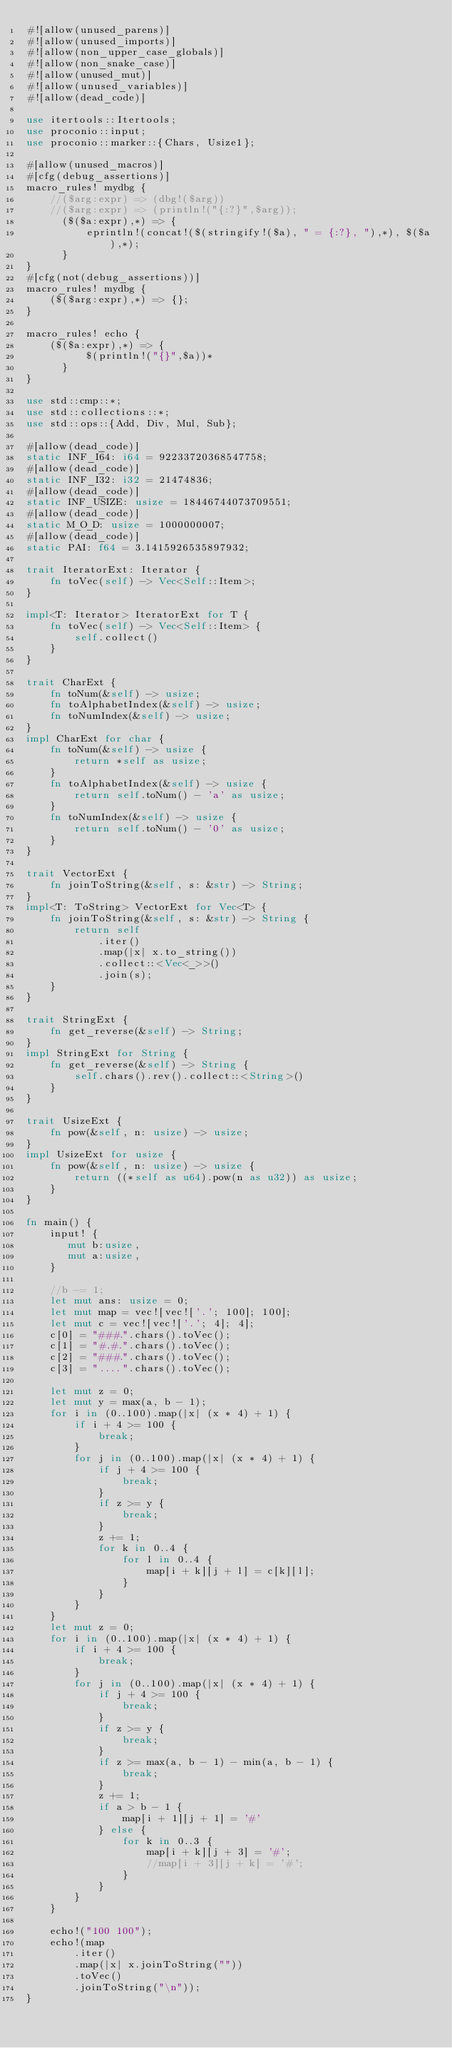Convert code to text. <code><loc_0><loc_0><loc_500><loc_500><_Rust_>#![allow(unused_parens)]
#![allow(unused_imports)]
#![allow(non_upper_case_globals)]
#![allow(non_snake_case)]
#![allow(unused_mut)]
#![allow(unused_variables)]
#![allow(dead_code)]

use itertools::Itertools;
use proconio::input;
use proconio::marker::{Chars, Usize1};

#[allow(unused_macros)]
#[cfg(debug_assertions)]
macro_rules! mydbg {
    //($arg:expr) => (dbg!($arg))
    //($arg:expr) => (println!("{:?}",$arg));
      ($($a:expr),*) => {
          eprintln!(concat!($(stringify!($a), " = {:?}, "),*), $($a),*);
      }
}
#[cfg(not(debug_assertions))]
macro_rules! mydbg {
    ($($arg:expr),*) => {};
}

macro_rules! echo {
    ($($a:expr),*) => {
          $(println!("{}",$a))*
      }
}

use std::cmp::*;
use std::collections::*;
use std::ops::{Add, Div, Mul, Sub};

#[allow(dead_code)]
static INF_I64: i64 = 92233720368547758;
#[allow(dead_code)]
static INF_I32: i32 = 21474836;
#[allow(dead_code)]
static INF_USIZE: usize = 18446744073709551;
#[allow(dead_code)]
static M_O_D: usize = 1000000007;
#[allow(dead_code)]
static PAI: f64 = 3.1415926535897932;

trait IteratorExt: Iterator {
    fn toVec(self) -> Vec<Self::Item>;
}

impl<T: Iterator> IteratorExt for T {
    fn toVec(self) -> Vec<Self::Item> {
        self.collect()
    }
}

trait CharExt {
    fn toNum(&self) -> usize;
    fn toAlphabetIndex(&self) -> usize;
    fn toNumIndex(&self) -> usize;
}
impl CharExt for char {
    fn toNum(&self) -> usize {
        return *self as usize;
    }
    fn toAlphabetIndex(&self) -> usize {
        return self.toNum() - 'a' as usize;
    }
    fn toNumIndex(&self) -> usize {
        return self.toNum() - '0' as usize;
    }
}

trait VectorExt {
    fn joinToString(&self, s: &str) -> String;
}
impl<T: ToString> VectorExt for Vec<T> {
    fn joinToString(&self, s: &str) -> String {
        return self
            .iter()
            .map(|x| x.to_string())
            .collect::<Vec<_>>()
            .join(s);
    }
}

trait StringExt {
    fn get_reverse(&self) -> String;
}
impl StringExt for String {
    fn get_reverse(&self) -> String {
        self.chars().rev().collect::<String>()
    }
}

trait UsizeExt {
    fn pow(&self, n: usize) -> usize;
}
impl UsizeExt for usize {
    fn pow(&self, n: usize) -> usize {
        return ((*self as u64).pow(n as u32)) as usize;
    }
}

fn main() {
    input! {
       mut b:usize,
       mut a:usize,
    }

    //b -= 1;
    let mut ans: usize = 0;
    let mut map = vec![vec!['.'; 100]; 100];
    let mut c = vec![vec!['.'; 4]; 4];
    c[0] = "###.".chars().toVec();
    c[1] = "#.#.".chars().toVec();
    c[2] = "###.".chars().toVec();
    c[3] = "....".chars().toVec();

    let mut z = 0;
    let mut y = max(a, b - 1);
    for i in (0..100).map(|x| (x * 4) + 1) {
        if i + 4 >= 100 {
            break;
        }
        for j in (0..100).map(|x| (x * 4) + 1) {
            if j + 4 >= 100 {
                break;
            }
            if z >= y {
                break;
            }
            z += 1;
            for k in 0..4 {
                for l in 0..4 {
                    map[i + k][j + l] = c[k][l];
                }
            }
        }
    }
    let mut z = 0;
    for i in (0..100).map(|x| (x * 4) + 1) {
        if i + 4 >= 100 {
            break;
        }
        for j in (0..100).map(|x| (x * 4) + 1) {
            if j + 4 >= 100 {
                break;
            }
            if z >= y {
                break;
            }
            if z >= max(a, b - 1) - min(a, b - 1) {
                break;
            }
            z += 1;
            if a > b - 1 {
                map[i + 1][j + 1] = '#'
            } else {
                for k in 0..3 {
                    map[i + k][j + 3] = '#';
                    //map[i + 3][j + k] = '#';
                }
            }
        }
    }

    echo!("100 100");
    echo!(map
        .iter()
        .map(|x| x.joinToString(""))
        .toVec()
        .joinToString("\n"));
}
</code> 